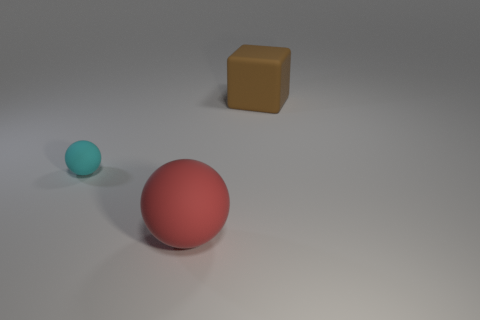Add 3 small objects. How many objects exist? 6 Subtract all spheres. How many objects are left? 1 Add 2 big red rubber balls. How many big red rubber balls are left? 3 Add 1 tiny brown cylinders. How many tiny brown cylinders exist? 1 Subtract 0 brown spheres. How many objects are left? 3 Subtract all brown matte cubes. Subtract all tiny yellow rubber cubes. How many objects are left? 2 